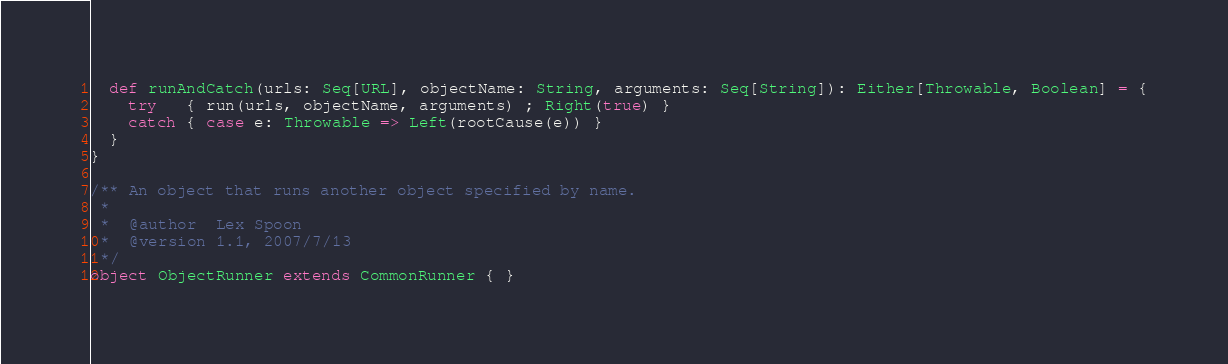<code> <loc_0><loc_0><loc_500><loc_500><_Scala_>  def runAndCatch(urls: Seq[URL], objectName: String, arguments: Seq[String]): Either[Throwable, Boolean] = {
    try   { run(urls, objectName, arguments) ; Right(true) }
    catch { case e: Throwable => Left(rootCause(e)) }
  }
}

/** An object that runs another object specified by name.
 *
 *  @author  Lex Spoon
 *  @version 1.1, 2007/7/13
 */
object ObjectRunner extends CommonRunner { }
</code> 